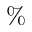Convert formula to latex. <formula><loc_0><loc_0><loc_500><loc_500>\%</formula> 